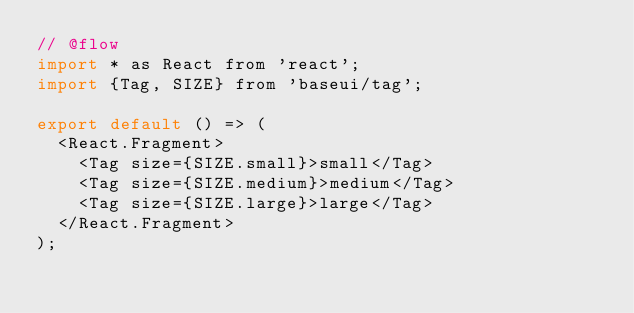<code> <loc_0><loc_0><loc_500><loc_500><_JavaScript_>// @flow
import * as React from 'react';
import {Tag, SIZE} from 'baseui/tag';

export default () => (
  <React.Fragment>
    <Tag size={SIZE.small}>small</Tag>
    <Tag size={SIZE.medium}>medium</Tag>
    <Tag size={SIZE.large}>large</Tag>
  </React.Fragment>
);
</code> 